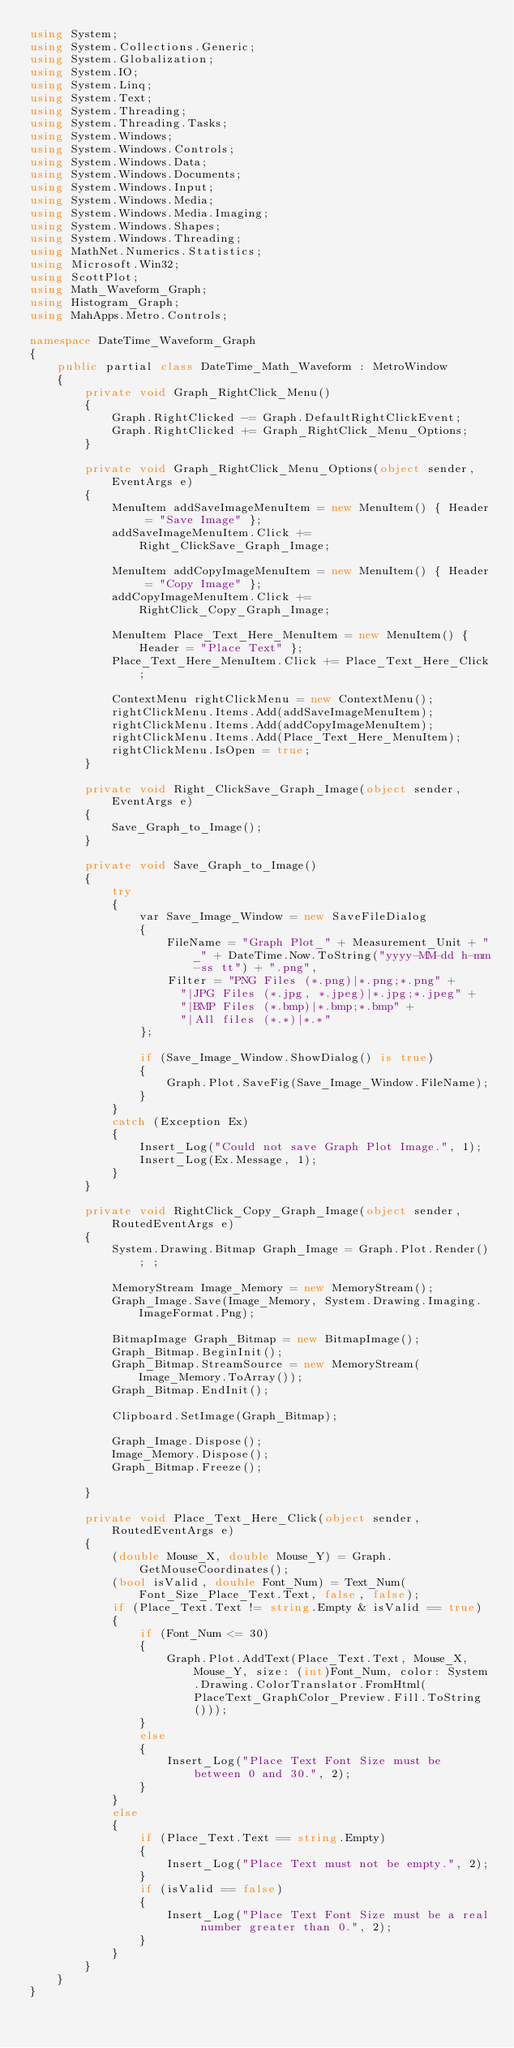<code> <loc_0><loc_0><loc_500><loc_500><_C#_>using System;
using System.Collections.Generic;
using System.Globalization;
using System.IO;
using System.Linq;
using System.Text;
using System.Threading;
using System.Threading.Tasks;
using System.Windows;
using System.Windows.Controls;
using System.Windows.Data;
using System.Windows.Documents;
using System.Windows.Input;
using System.Windows.Media;
using System.Windows.Media.Imaging;
using System.Windows.Shapes;
using System.Windows.Threading;
using MathNet.Numerics.Statistics;
using Microsoft.Win32;
using ScottPlot;
using Math_Waveform_Graph;
using Histogram_Graph;
using MahApps.Metro.Controls;

namespace DateTime_Waveform_Graph
{
    public partial class DateTime_Math_Waveform : MetroWindow
    {
        private void Graph_RightClick_Menu()
        {
            Graph.RightClicked -= Graph.DefaultRightClickEvent;
            Graph.RightClicked += Graph_RightClick_Menu_Options;
        }

        private void Graph_RightClick_Menu_Options(object sender, EventArgs e)
        {
            MenuItem addSaveImageMenuItem = new MenuItem() { Header = "Save Image" };
            addSaveImageMenuItem.Click += Right_ClickSave_Graph_Image;

            MenuItem addCopyImageMenuItem = new MenuItem() { Header = "Copy Image" };
            addCopyImageMenuItem.Click += RightClick_Copy_Graph_Image;

            MenuItem Place_Text_Here_MenuItem = new MenuItem() { Header = "Place Text" };
            Place_Text_Here_MenuItem.Click += Place_Text_Here_Click;

            ContextMenu rightClickMenu = new ContextMenu();
            rightClickMenu.Items.Add(addSaveImageMenuItem);
            rightClickMenu.Items.Add(addCopyImageMenuItem);
            rightClickMenu.Items.Add(Place_Text_Here_MenuItem);
            rightClickMenu.IsOpen = true;
        }

        private void Right_ClickSave_Graph_Image(object sender, EventArgs e)
        {
            Save_Graph_to_Image();
        }

        private void Save_Graph_to_Image()
        {
            try
            {
                var Save_Image_Window = new SaveFileDialog
                {
                    FileName = "Graph Plot_" + Measurement_Unit + "_" + DateTime.Now.ToString("yyyy-MM-dd h-mm-ss tt") + ".png",
                    Filter = "PNG Files (*.png)|*.png;*.png" +
                      "|JPG Files (*.jpg, *.jpeg)|*.jpg;*.jpeg" +
                      "|BMP Files (*.bmp)|*.bmp;*.bmp" +
                      "|All files (*.*)|*.*"
                };

                if (Save_Image_Window.ShowDialog() is true)
                {
                    Graph.Plot.SaveFig(Save_Image_Window.FileName);
                }
            }
            catch (Exception Ex)
            {
                Insert_Log("Could not save Graph Plot Image.", 1);
                Insert_Log(Ex.Message, 1);
            }
        }

        private void RightClick_Copy_Graph_Image(object sender, RoutedEventArgs e)
        {
            System.Drawing.Bitmap Graph_Image = Graph.Plot.Render(); ;

            MemoryStream Image_Memory = new MemoryStream();
            Graph_Image.Save(Image_Memory, System.Drawing.Imaging.ImageFormat.Png);

            BitmapImage Graph_Bitmap = new BitmapImage();
            Graph_Bitmap.BeginInit();
            Graph_Bitmap.StreamSource = new MemoryStream(Image_Memory.ToArray());
            Graph_Bitmap.EndInit();

            Clipboard.SetImage(Graph_Bitmap);

            Graph_Image.Dispose();
            Image_Memory.Dispose();
            Graph_Bitmap.Freeze();

        }

        private void Place_Text_Here_Click(object sender, RoutedEventArgs e)
        {
            (double Mouse_X, double Mouse_Y) = Graph.GetMouseCoordinates();
            (bool isValid, double Font_Num) = Text_Num(Font_Size_Place_Text.Text, false, false);
            if (Place_Text.Text != string.Empty & isValid == true)
            {
                if (Font_Num <= 30)
                {
                    Graph.Plot.AddText(Place_Text.Text, Mouse_X, Mouse_Y, size: (int)Font_Num, color: System.Drawing.ColorTranslator.FromHtml(PlaceText_GraphColor_Preview.Fill.ToString()));
                }
                else
                {
                    Insert_Log("Place Text Font Size must be between 0 and 30.", 2);
                }
            }
            else
            {
                if (Place_Text.Text == string.Empty)
                {
                    Insert_Log("Place Text must not be empty.", 2);
                }
                if (isValid == false)
                {
                    Insert_Log("Place Text Font Size must be a real number greater than 0.", 2);
                }
            }
        }
    }
}</code> 